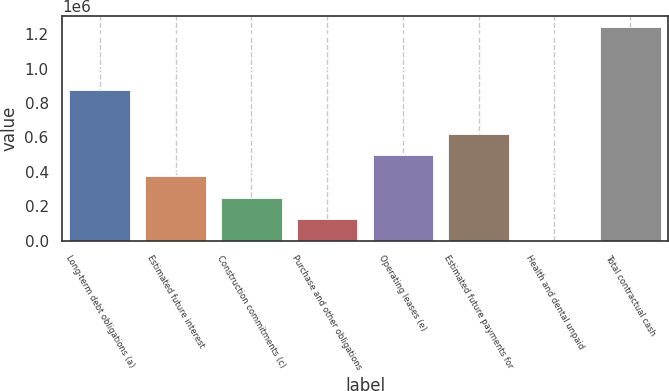Convert chart. <chart><loc_0><loc_0><loc_500><loc_500><bar_chart><fcel>Long-term debt obligations (a)<fcel>Estimated future interest<fcel>Construction commitments (c)<fcel>Purchase and other obligations<fcel>Operating leases (e)<fcel>Estimated future payments for<fcel>Health and dental unpaid<fcel>Total contractual cash<nl><fcel>875340<fcel>373115<fcel>248744<fcel>124373<fcel>497486<fcel>621857<fcel>2.22<fcel>1.24371e+06<nl></chart> 